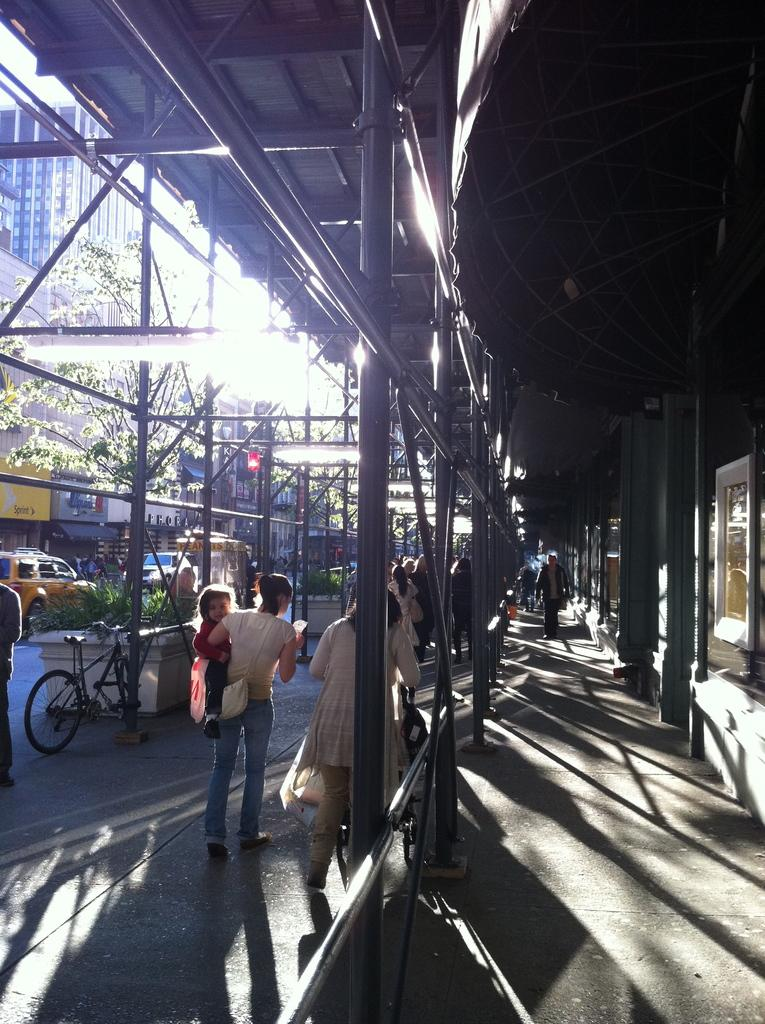What are the people in the image doing? The people in the image are walking on the road. What is visible at the top of the image? There is a roof visible at the top of the image. What can be seen on the left side of the image? There are buildings and trees on the left side of the image. What else is present on the road besides the people? There are cars and vehicles on the road. Who is the owner of the cork in the image? There is no cork present in the image. What type of error can be seen in the image? There is no error visible in the image. 